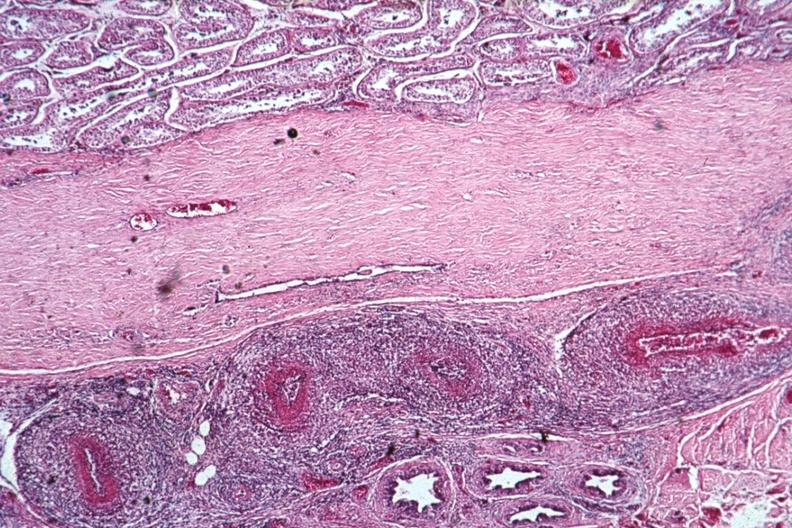what does this image show?
Answer the question using a single word or phrase. Well shown vasculitis lesion of pan type 